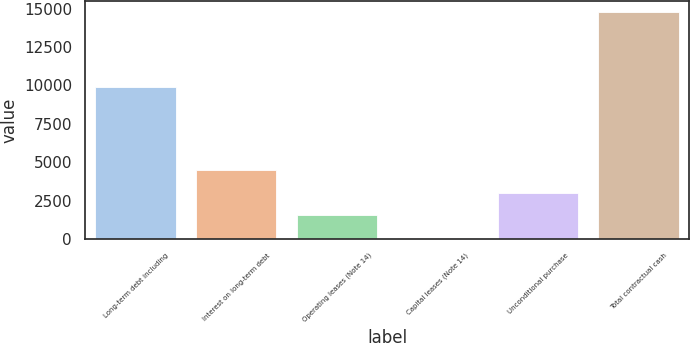Convert chart. <chart><loc_0><loc_0><loc_500><loc_500><bar_chart><fcel>Long-term debt including<fcel>Interest on long-term debt<fcel>Operating leases (Note 14)<fcel>Capital leases (Note 14)<fcel>Unconditional purchase<fcel>Total contractual cash<nl><fcel>9878<fcel>4467.8<fcel>1528.6<fcel>59<fcel>2998.2<fcel>14755<nl></chart> 